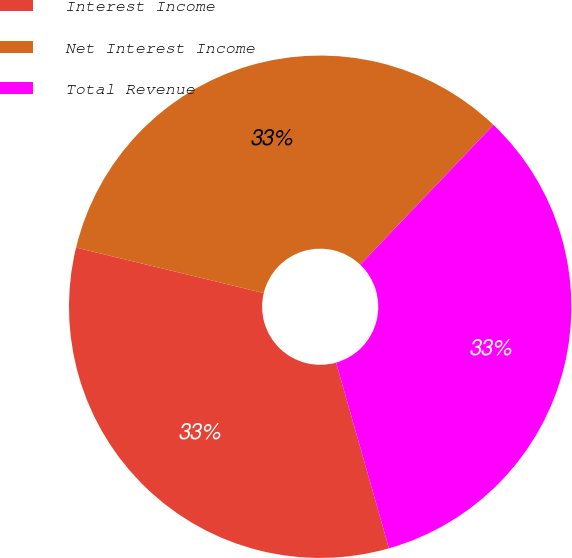Convert chart. <chart><loc_0><loc_0><loc_500><loc_500><pie_chart><fcel>Interest Income<fcel>Net Interest Income<fcel>Total Revenue<nl><fcel>33.2%<fcel>33.33%<fcel>33.47%<nl></chart> 